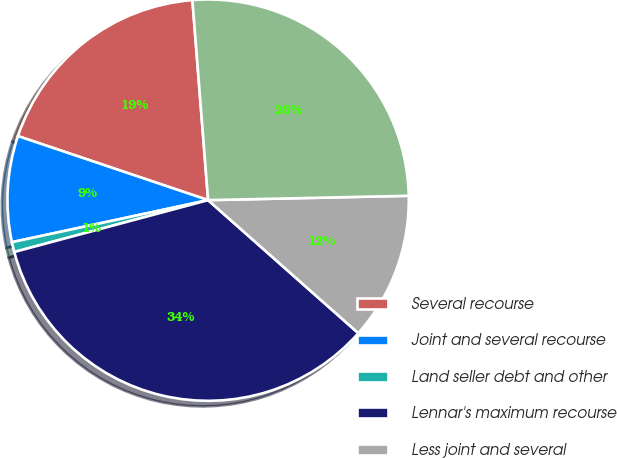Convert chart. <chart><loc_0><loc_0><loc_500><loc_500><pie_chart><fcel>Several recourse<fcel>Joint and several recourse<fcel>Land seller debt and other<fcel>Lennar's maximum recourse<fcel>Less joint and several<fcel>Lennar's net recourse exposure<nl><fcel>18.58%<fcel>8.53%<fcel>0.8%<fcel>34.3%<fcel>11.88%<fcel>25.9%<nl></chart> 